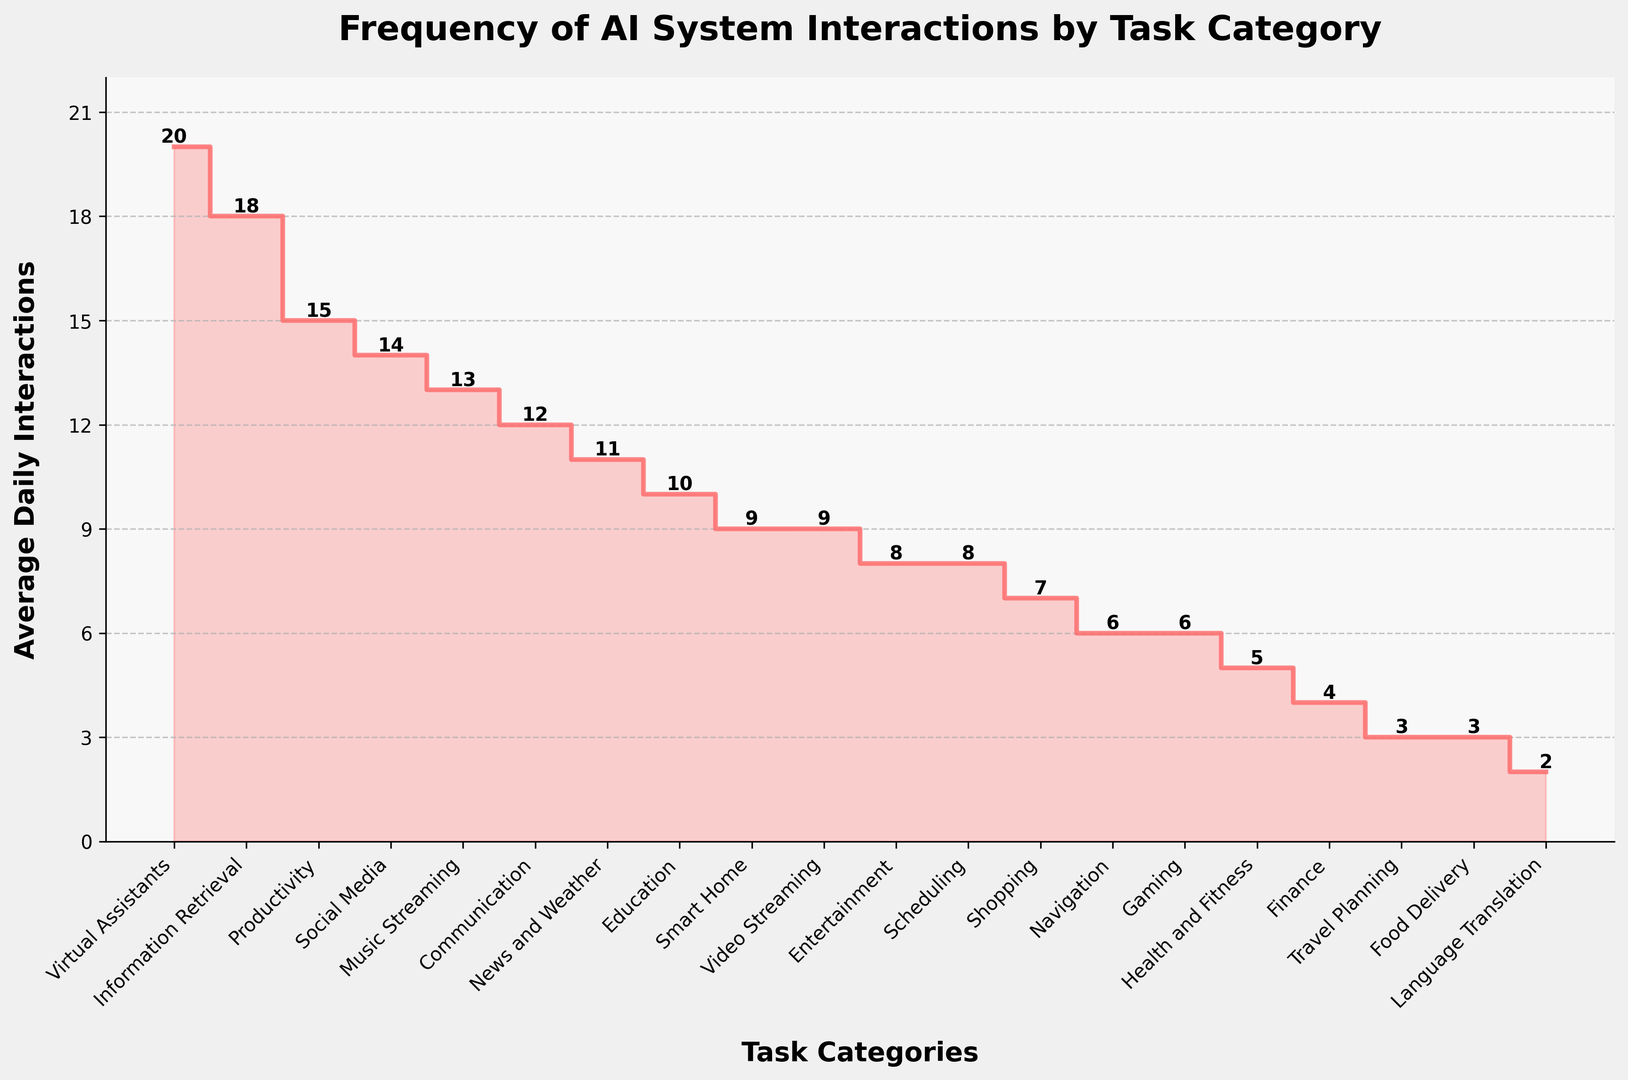Which task category has the highest average daily interactions? First, identify the step with the highest vertical value on the plot. According to the y-axis, the highest average daily interaction is 20. Then, match this value with the corresponding task category on the x-axis, which is "Virtual Assistants".
Answer: Virtual Assistants Which task category has fewer average daily interactions, "Music Streaming" or "Gaming"? Locate both categories on the x-axis and compare their y-values. "Music Streaming" has a value of 13, whereas "Gaming" has a value of 6. Since 6 is less than 13, "Gaming" has fewer average daily interactions.
Answer: Gaming What is the difference in average daily interactions between "Information Retrieval" and "Finance"? Identify the y-values for both tasks: "Information Retrieval" has 18 and "Finance" has 4. Calculate the difference: 18 - 4 = 14.
Answer: 14 Among "Navigation", "Shopping", and "Food Delivery", which task has the lowest average daily interactions? Locate all three tasks on the x-axis and compare their y-values. "Navigation" has 6, "Shopping" has 7, and "Food Delivery" has 3. Since 3 is the smallest, "Food Delivery" has the lowest average daily interactions among the three.
Answer: Food Delivery What is the sum of average daily interactions for "Communication" and "Social Media"? Identify the y-values for both tasks: "Communication" has 12 and "Social Media" has 14. Sum these values: 12 + 14 = 26.
Answer: 26 Is the average daily interaction for "News and Weather" greater than the median average daily interaction across all task categories? First, get the value for "News and Weather," which is 11. To find the median, list all values and find the middle point: [2, 3, 3, 4, 5, 6, 6, 7, 8, 8, 9, 9, 10, 11, 12, 13, 14, 15, 18, 20]. The median value (middle value) is (9+9)/2 = 9. Compare 11 with the median: 11 > 9.
Answer: Yes What is the combined total daily interactions for the top three most interacted task categories? Identify the top three y-values: 20 ("Virtual Assistants"), 18 ("Information Retrieval"), and 15 ("Productivity"). Sum these values: 20 + 18 + 15 = 53.
Answer: 53 